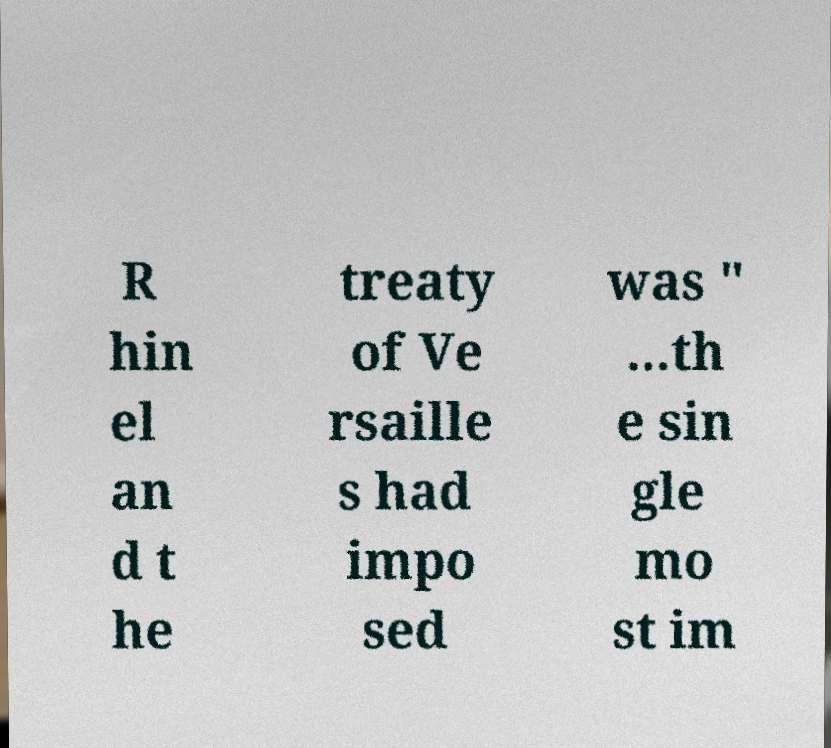I need the written content from this picture converted into text. Can you do that? R hin el an d t he treaty of Ve rsaille s had impo sed was " ...th e sin gle mo st im 